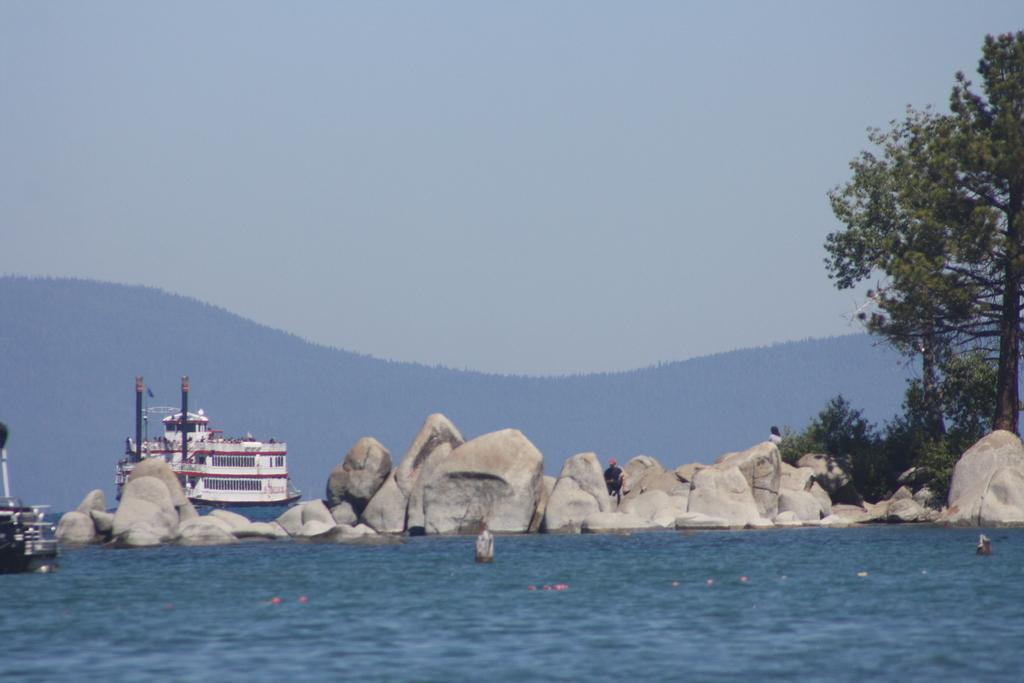How would you summarize this image in a sentence or two? At the bottom of the picture, we see water. In the middle of the picture, the man in black jacket is sitting on the rocks. Beside that, we see a boat. On the right side, we see trees and plants. There are trees and hills in the background. At the top of the picture, we see the sky. 